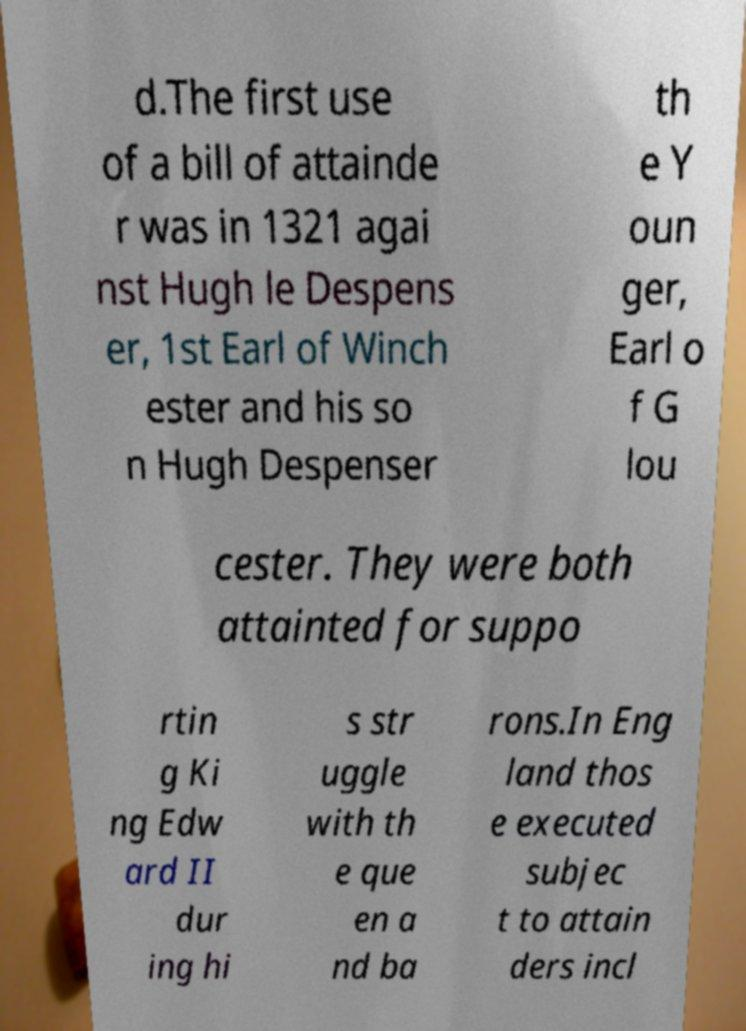I need the written content from this picture converted into text. Can you do that? d.The first use of a bill of attainde r was in 1321 agai nst Hugh le Despens er, 1st Earl of Winch ester and his so n Hugh Despenser th e Y oun ger, Earl o f G lou cester. They were both attainted for suppo rtin g Ki ng Edw ard II dur ing hi s str uggle with th e que en a nd ba rons.In Eng land thos e executed subjec t to attain ders incl 